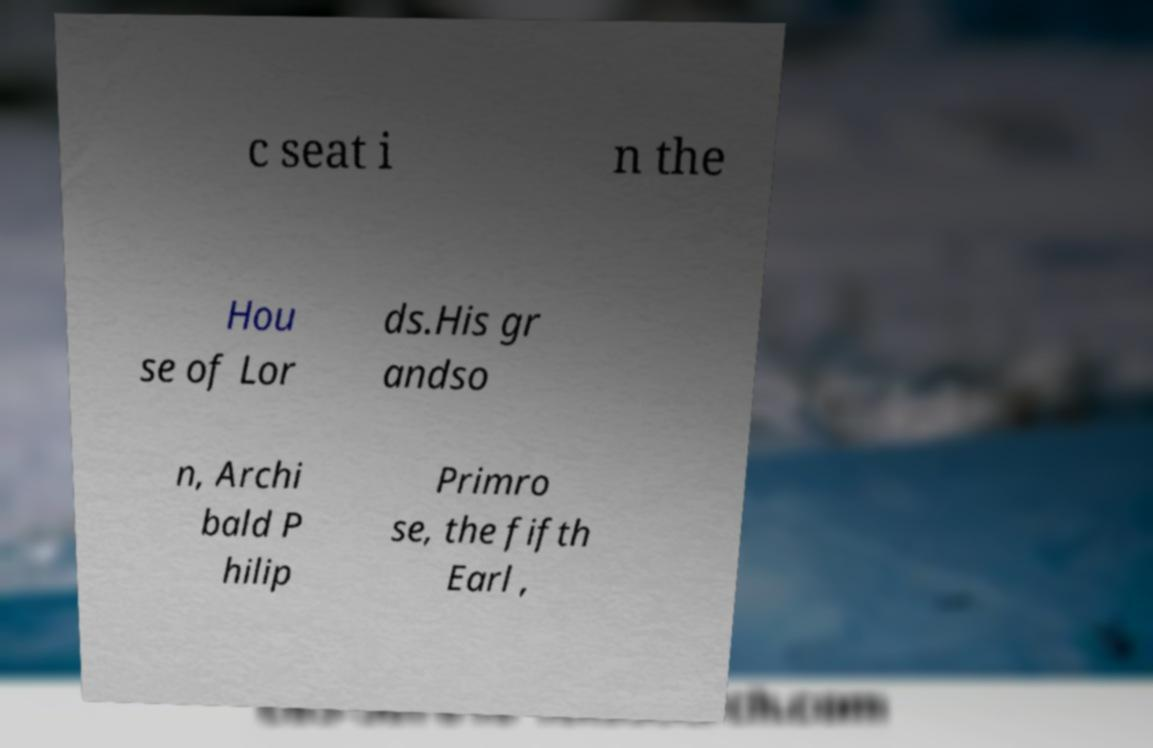What messages or text are displayed in this image? I need them in a readable, typed format. c seat i n the Hou se of Lor ds.His gr andso n, Archi bald P hilip Primro se, the fifth Earl , 